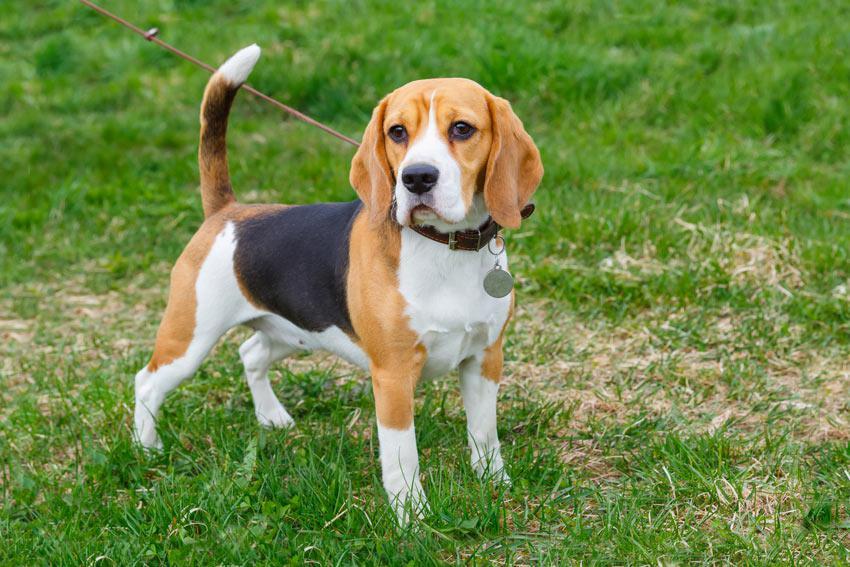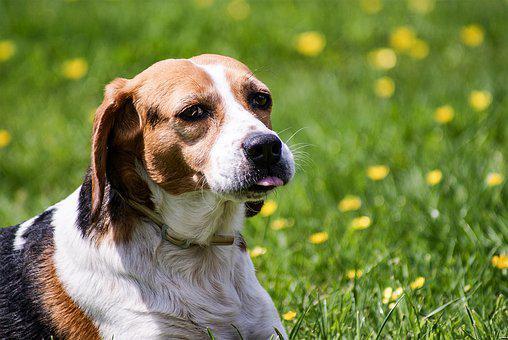The first image is the image on the left, the second image is the image on the right. Analyze the images presented: Is the assertion "In one of the images there is a single beagle standing outside." valid? Answer yes or no. Yes. 